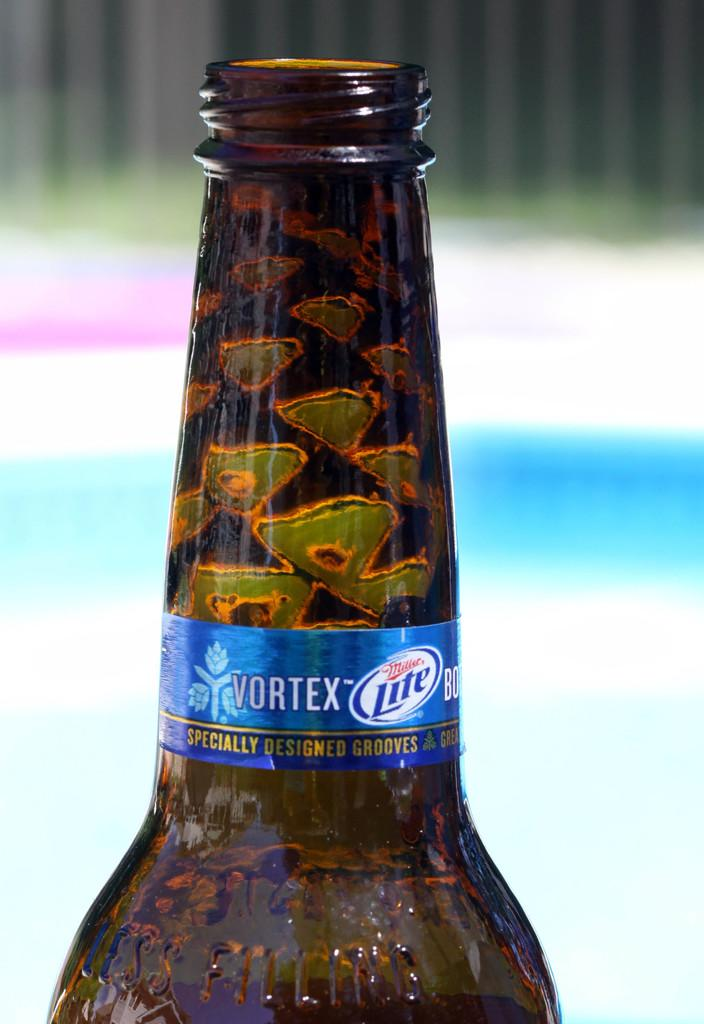Provide a one-sentence caption for the provided image. The top of a Miller Lite Vortex bottle has specially designed grooves. 